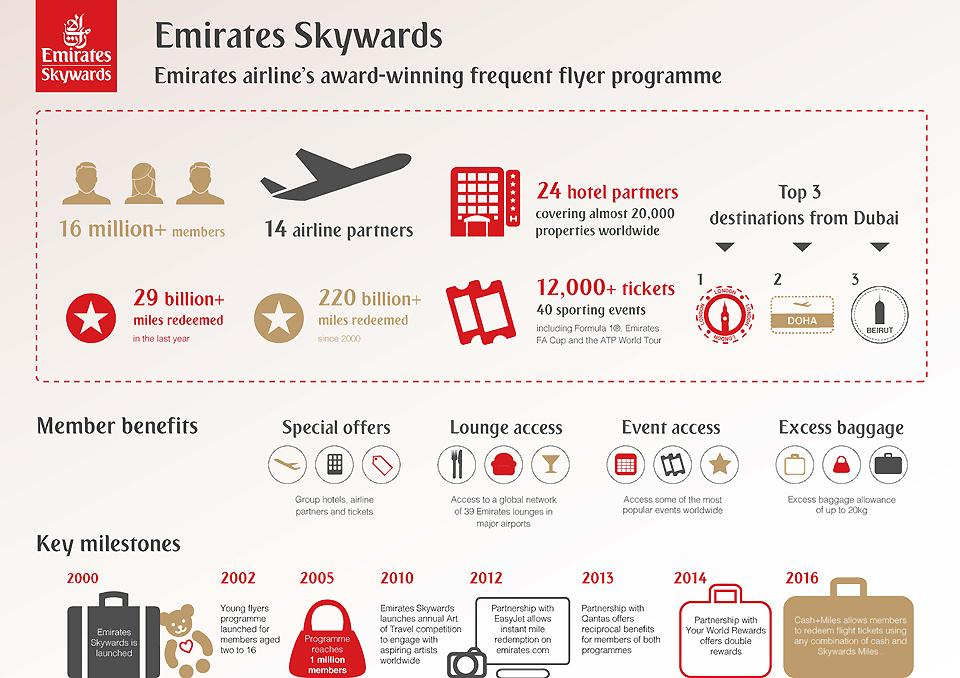Draw attention to some important aspects in this diagram. Emirates Skywards was launched in 2000. The red bag contains the written message "Program reaches 1 million members. The Young Flyers Program is designed for members aged two to 16. By partnering with EasyJet, Emirates customers can instantly redeem miles for flights on the airline. There have been four member benefits that have been demonstrated. 